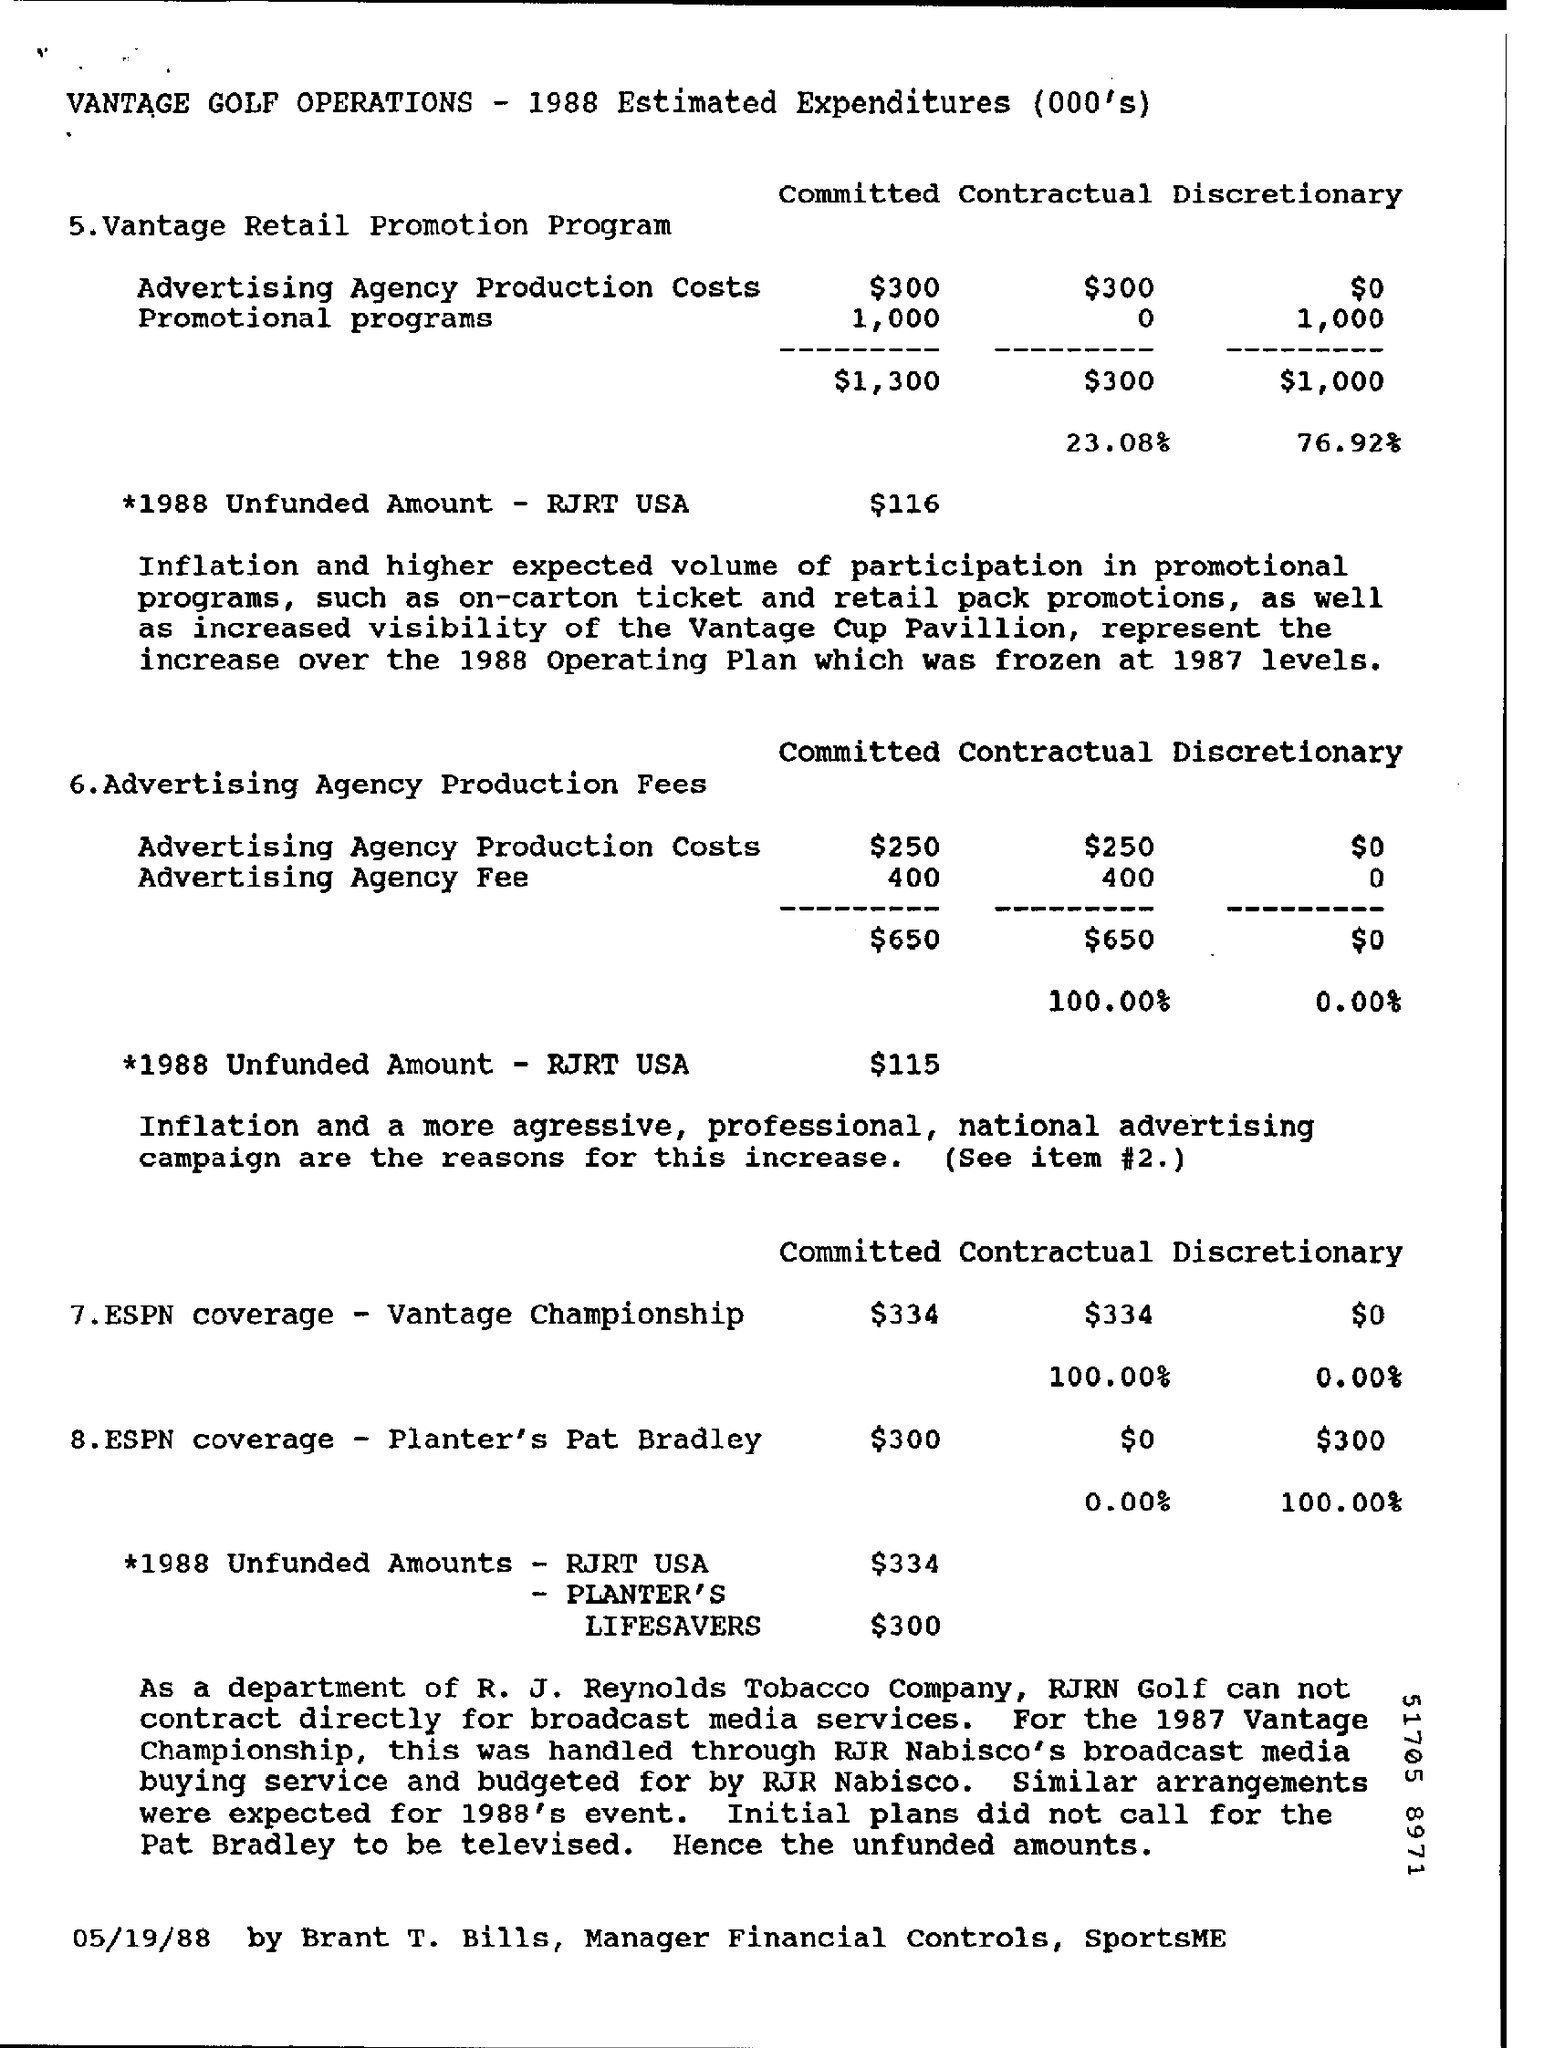What is the amount Unfunded for PLANTER'S LIFESAVERS?
Give a very brief answer. $300. 